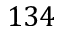Convert formula to latex. <formula><loc_0><loc_0><loc_500><loc_500>1 3 4</formula> 